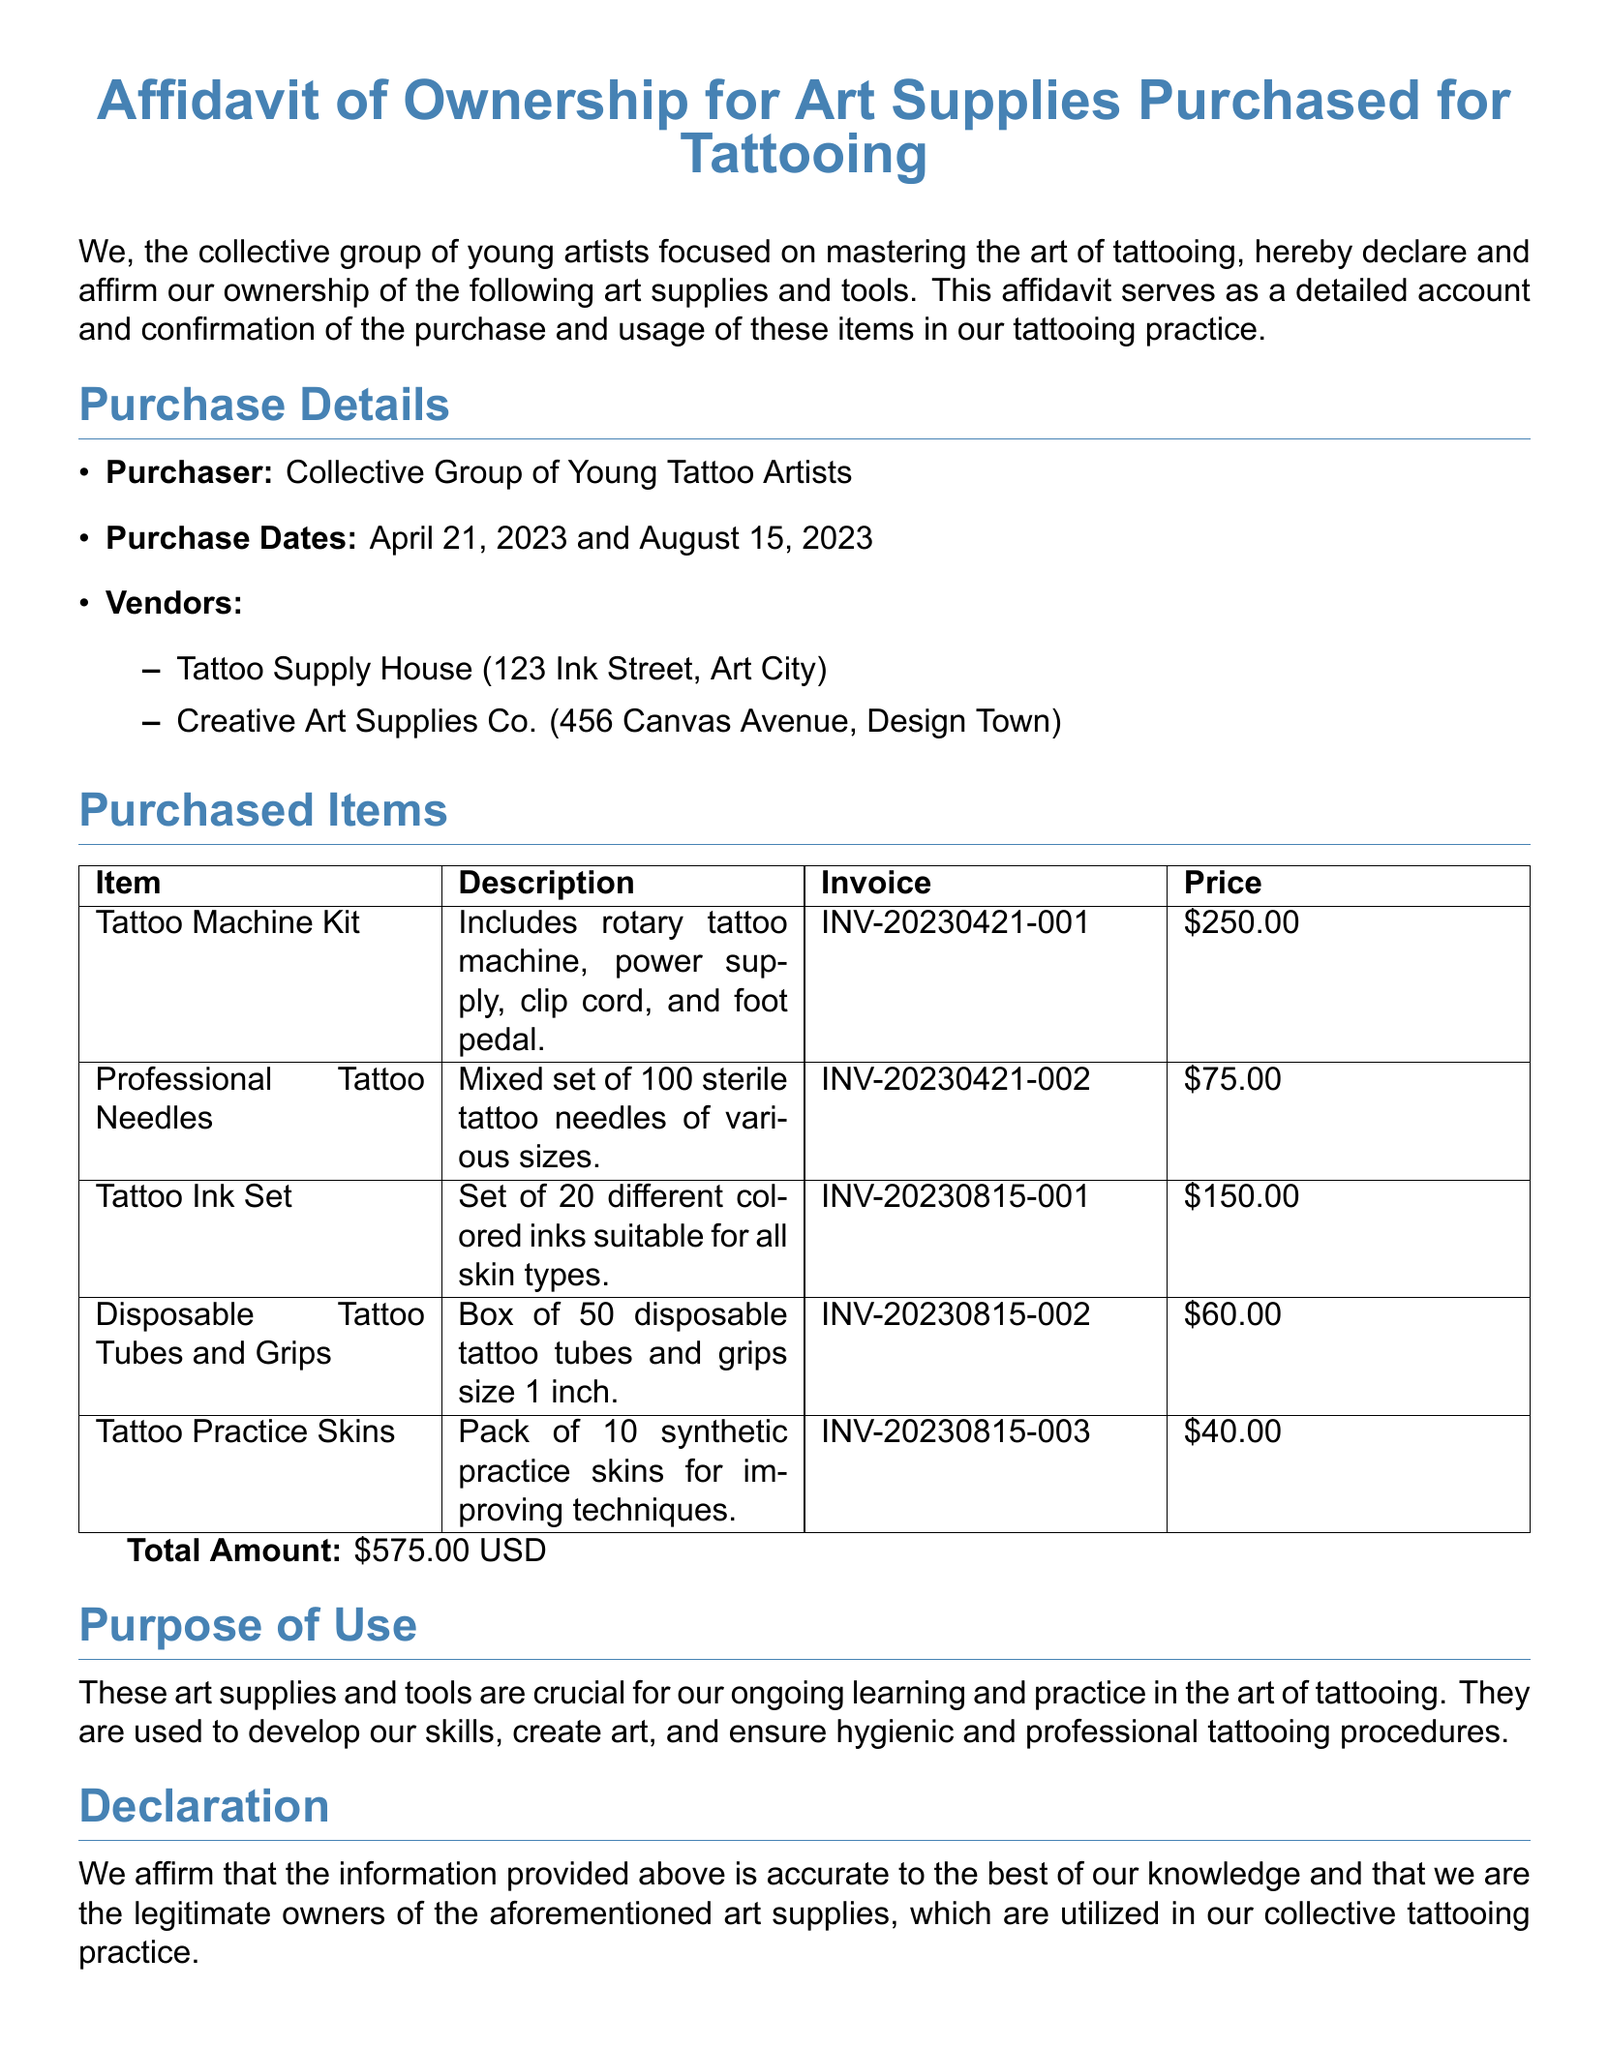What is the total amount for the purchased items? The total amount is stated at the end of the purchased items section, which sums up the prices.
Answer: $575.00 USD Who is the lead artist that signed the affidavit? The document lists Alex Johnson as the lead artist in the signatures section.
Answer: Alex Johnson What is the purpose of the purchased supplies? The purpose of the supplies is detailed in the purpose of use section, explaining why they are essential to the artists.
Answer: Ongoing learning and practice When were the purchases made? The purchase dates are specified in the purchase details section, listing the exact dates.
Answer: April 21, 2023 and August 15, 2023 Which vendor provided the tattoo ink set? The vendors are mentioned in the purchase details, and the tattoo ink set is linked to Creative Art Supplies Co.
Answer: Creative Art Supplies Co How many disposable tattoo tubes and grips were purchased? The quantity is described in the purchased items section next to the item name.
Answer: Box of 50 What types of items are included in the tattoo machine kit? The description of the tattoo machine kit details its contents in the purchased items section.
Answer: Rotary tattoo machine, power supply, clip cord, and foot pedal What is the invoice number for the professional tattoo needles? The invoice number is provided in the table alongside the item description.
Answer: INV-20230421-002 